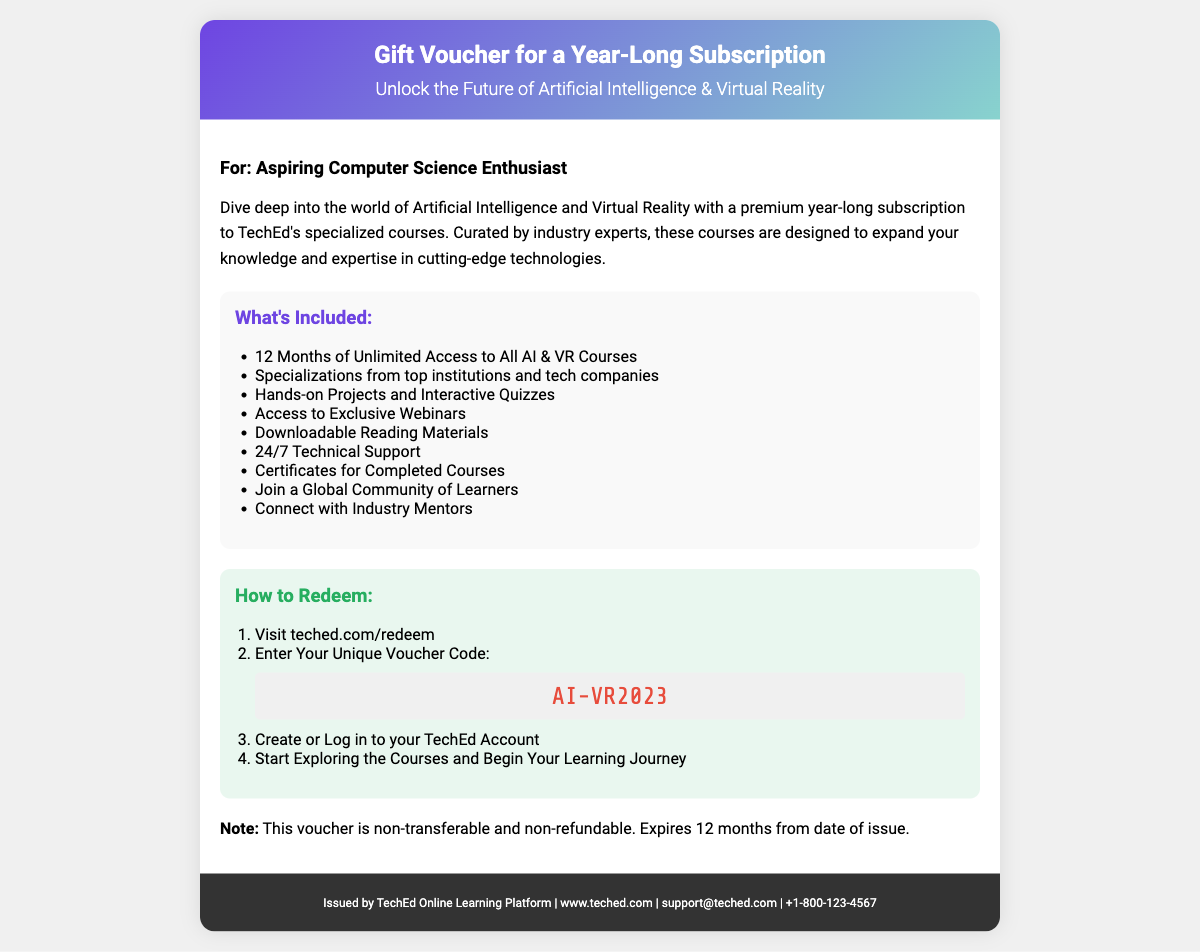What is the title of the voucher? The title is presented at the top of the document, indicating the nature of the voucher.
Answer: Gift Voucher for a Year-Long Subscription Who is the recipient described in the document? The document specifies a target audience for the voucher, revealing whom it is intended for.
Answer: Aspiring Computer Science Enthusiast How many months of access does the subscription provide? The detailed description of what's included lists the duration of access to the courses.
Answer: 12 Months What is the unique voucher code? The document explicitly mentions a specific code required for redeeming the voucher.
Answer: AI-VR2023 What types of projects are included in the courses? The features section outlines the kinds of activities learners will engage in during the subscription.
Answer: Hands-on Projects Is the voucher transferable? The last note in the document clarifies the voucher's policy regarding transferability.
Answer: Non-transferable What kind of support is available for users? The features section mentions a specific type of assistance provided during the course subscription.
Answer: 24/7 Technical Support Where can the voucher be redeemed? The redemption instructions specify a website for using the voucher code.
Answer: teched.com/redeem What is the expiration policy for the voucher? The last note in the content section provides a detail about the validity timeline.
Answer: 12 months from date of issue 